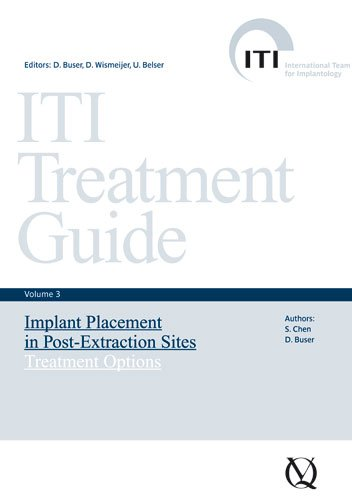What is the title of this book? The full title of the book is 'ITI Treatment Guide, Volume 3: Implant Placement in Post-Extraction Sites: Treatment Options', part of a series providing detailed guidelines on dental procedures. 